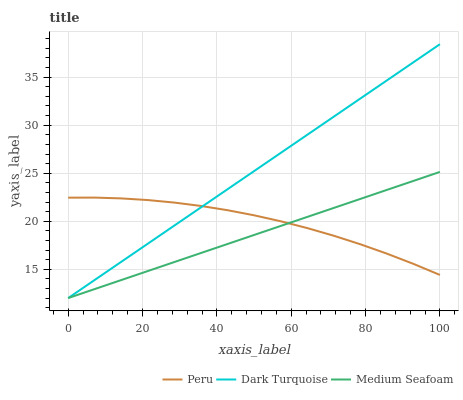Does Medium Seafoam have the minimum area under the curve?
Answer yes or no. Yes. Does Dark Turquoise have the maximum area under the curve?
Answer yes or no. Yes. Does Peru have the minimum area under the curve?
Answer yes or no. No. Does Peru have the maximum area under the curve?
Answer yes or no. No. Is Dark Turquoise the smoothest?
Answer yes or no. Yes. Is Peru the roughest?
Answer yes or no. Yes. Is Medium Seafoam the smoothest?
Answer yes or no. No. Is Medium Seafoam the roughest?
Answer yes or no. No. Does Dark Turquoise have the lowest value?
Answer yes or no. Yes. Does Peru have the lowest value?
Answer yes or no. No. Does Dark Turquoise have the highest value?
Answer yes or no. Yes. Does Medium Seafoam have the highest value?
Answer yes or no. No. Does Peru intersect Dark Turquoise?
Answer yes or no. Yes. Is Peru less than Dark Turquoise?
Answer yes or no. No. Is Peru greater than Dark Turquoise?
Answer yes or no. No. 